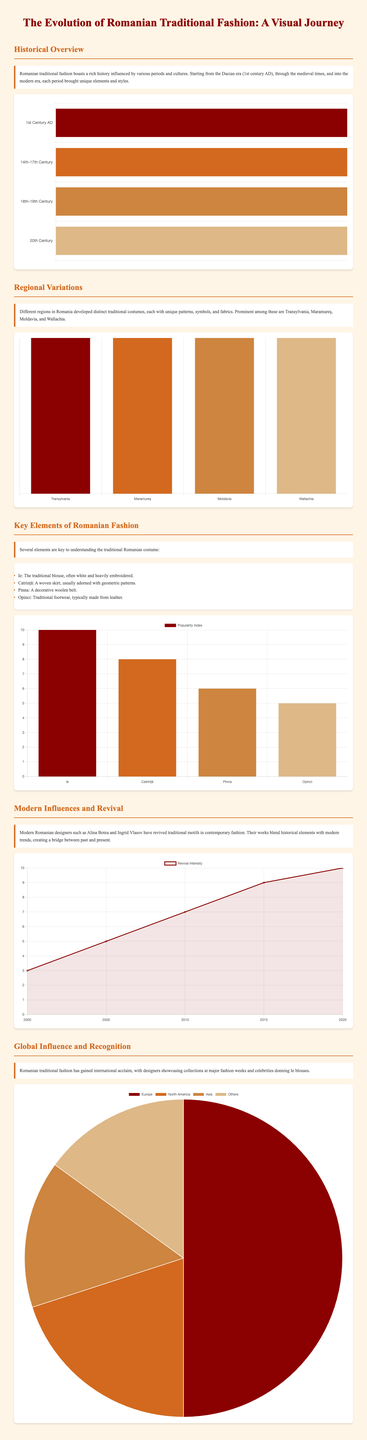what is the first historical period mentioned? The document lists the first historical period as the Dacian era, which is part of its timeline chart.
Answer: Dacian era how many regional variations are highlighted? The section on regional variations mentions four distinct regions in Romania.
Answer: Four what are the key elements of Romanian fashion? The list under "Key Elements of Romanian Fashion" includes four specific elements.
Answer: Four what year marks the peak of revival intensity? The revival intensity chart shows the highest value reaching its peak in the year 2020.
Answer: 2020 which region is associated with rich embroidery? The bar chart on regional variations indicates that Maramureș is known for its rich embroidery.
Answer: Maramureș what type of chart is used to represent global influence? The global influence data is presented as a pie chart.
Answer: Pie chart what is the popularity index of Opinci? The key elements chart shows that Opinci has a popularity index of 5.
Answer: 5 which designer is mentioned as a modern influencer? Alina Botea is cited as a modern designer who has contributed to the revival of traditional motifs.
Answer: Alina Botea what color represents the Ottoman Empire influence in the timeline chart? The color used for the Ottoman Empire in the timeline chart is a shade of brown represented as #CD853F.
Answer: Brown 